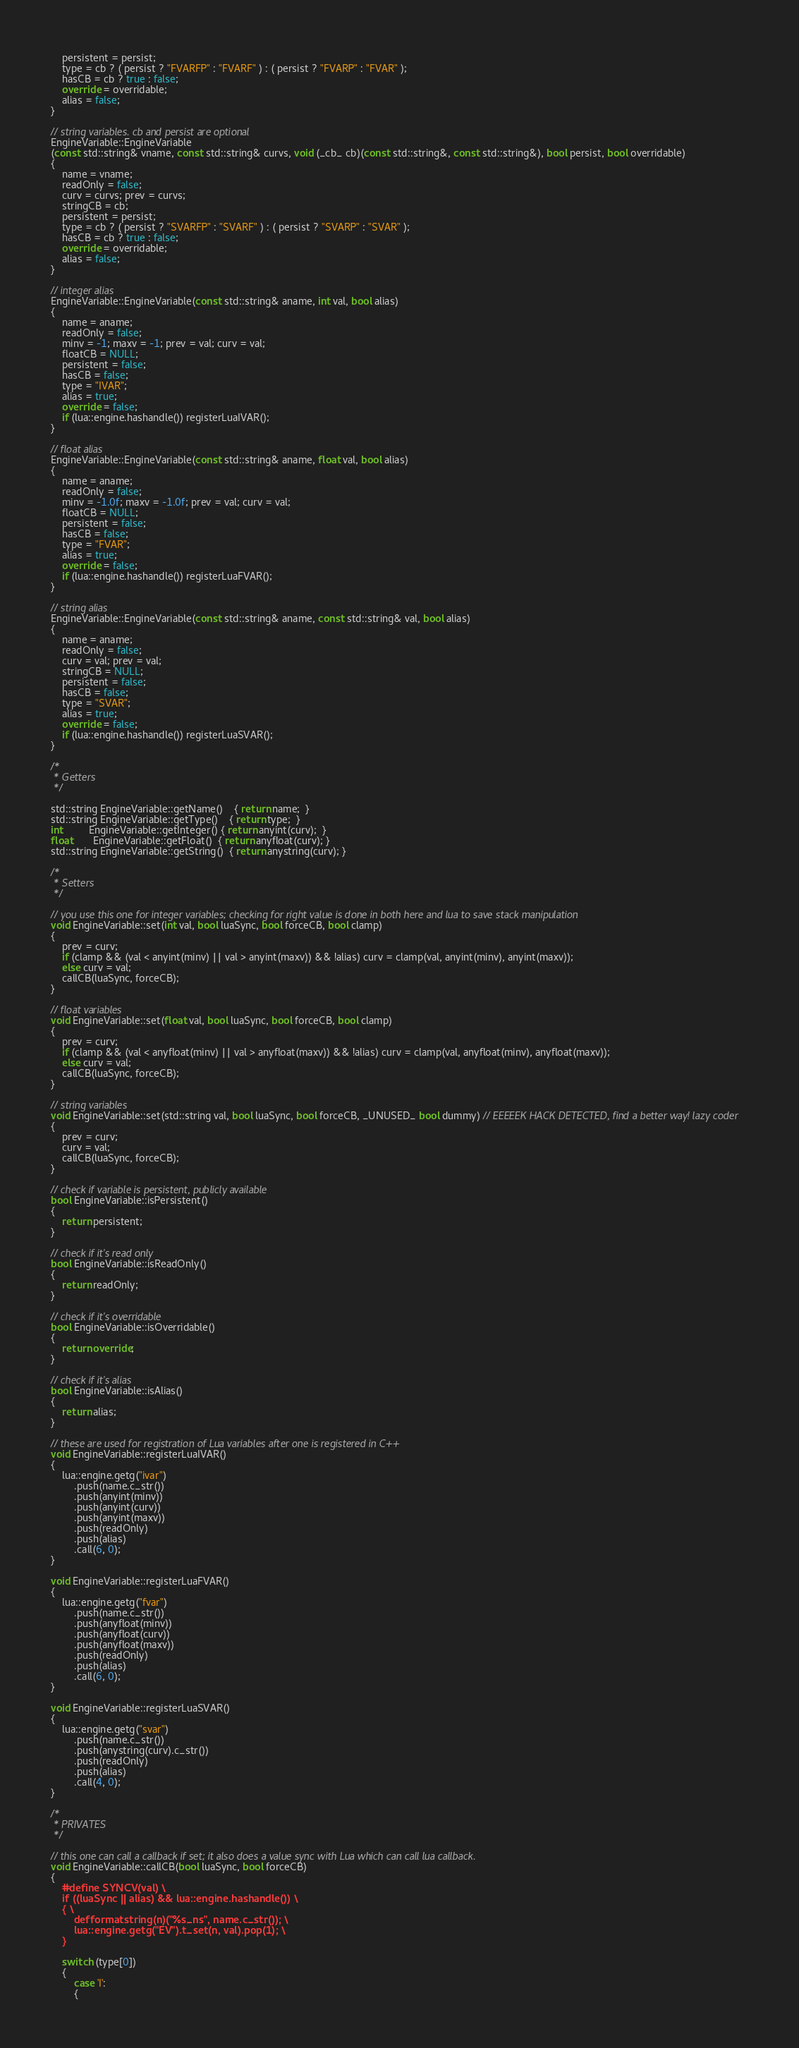Convert code to text. <code><loc_0><loc_0><loc_500><loc_500><_C++_>    persistent = persist;
    type = cb ? ( persist ? "FVARFP" : "FVARF" ) : ( persist ? "FVARP" : "FVAR" );
    hasCB = cb ? true : false;
    override = overridable;
    alias = false;
}

// string variables. cb and persist are optional
EngineVariable::EngineVariable
(const std::string& vname, const std::string& curvs, void (_cb_ cb)(const std::string&, const std::string&), bool persist, bool overridable)
{
    name = vname;
    readOnly = false;
    curv = curvs; prev = curvs;
    stringCB = cb;
    persistent = persist;
    type = cb ? ( persist ? "SVARFP" : "SVARF" ) : ( persist ? "SVARP" : "SVAR" );
    hasCB = cb ? true : false;
    override = overridable;
    alias = false;
}

// integer alias
EngineVariable::EngineVariable(const std::string& aname, int val, bool alias)
{
    name = aname;
    readOnly = false;
    minv = -1; maxv = -1; prev = val; curv = val;
    floatCB = NULL;
    persistent = false;
    hasCB = false;
    type = "IVAR";
    alias = true;
    override = false;
    if (lua::engine.hashandle()) registerLuaIVAR();
}

// float alias
EngineVariable::EngineVariable(const std::string& aname, float val, bool alias)
{
    name = aname;
    readOnly = false;
    minv = -1.0f; maxv = -1.0f; prev = val; curv = val;
    floatCB = NULL;
    persistent = false;
    hasCB = false;
    type = "FVAR";
    alias = true;
    override = false;
    if (lua::engine.hashandle()) registerLuaFVAR();
}

// string alias
EngineVariable::EngineVariable(const std::string& aname, const std::string& val, bool alias)
{
    name = aname;
    readOnly = false;
    curv = val; prev = val;
    stringCB = NULL;
    persistent = false;
    hasCB = false;
    type = "SVAR";
    alias = true;
    override = false;
    if (lua::engine.hashandle()) registerLuaSVAR();
}

/*
 * Getters
 */

std::string EngineVariable::getName()    { return name;  }
std::string EngineVariable::getType()    { return type;  }
int         EngineVariable::getInteger() { return anyint(curv);  }
float       EngineVariable::getFloat()  { return anyfloat(curv); }
std::string EngineVariable::getString()  { return anystring(curv); }

/*
 * Setters
 */

// you use this one for integer variables; checking for right value is done in both here and lua to save stack manipulation
void EngineVariable::set(int val, bool luaSync, bool forceCB, bool clamp)
{
    prev = curv;
    if (clamp && (val < anyint(minv) || val > anyint(maxv)) && !alias) curv = clamp(val, anyint(minv), anyint(maxv));
    else curv = val;
    callCB(luaSync, forceCB);
}

// float variables
void EngineVariable::set(float val, bool luaSync, bool forceCB, bool clamp)
{
    prev = curv;
    if (clamp && (val < anyfloat(minv) || val > anyfloat(maxv)) && !alias) curv = clamp(val, anyfloat(minv), anyfloat(maxv));
    else curv = val;
    callCB(luaSync, forceCB);
}

// string variables
void EngineVariable::set(std::string val, bool luaSync, bool forceCB, _UNUSED_ bool dummy) // EEEEEK HACK DETECTED, find a better way! lazy coder
{
    prev = curv;
    curv = val;
    callCB(luaSync, forceCB);
}

// check if variable is persistent, publicly available
bool EngineVariable::isPersistent()
{
    return persistent;
}

// check if it's read only
bool EngineVariable::isReadOnly()
{
    return readOnly;
}

// check if it's overridable
bool EngineVariable::isOverridable()
{
    return override;
}

// check if it's alias
bool EngineVariable::isAlias()
{
    return alias;
}

// these are used for registration of Lua variables after one is registered in C++
void EngineVariable::registerLuaIVAR()
{
    lua::engine.getg("ivar")
        .push(name.c_str())
        .push(anyint(minv))
        .push(anyint(curv))
        .push(anyint(maxv))
        .push(readOnly)
        .push(alias)
        .call(6, 0);
}

void EngineVariable::registerLuaFVAR()
{
    lua::engine.getg("fvar")
        .push(name.c_str())
        .push(anyfloat(minv))
        .push(anyfloat(curv))
        .push(anyfloat(maxv))
        .push(readOnly)
        .push(alias)
        .call(6, 0);
}

void EngineVariable::registerLuaSVAR()
{
    lua::engine.getg("svar")
        .push(name.c_str())
        .push(anystring(curv).c_str())
        .push(readOnly)
        .push(alias)
        .call(4, 0);
}

/*
 * PRIVATES
 */

// this one can call a callback if set; it also does a value sync with Lua which can call lua callback.
void EngineVariable::callCB(bool luaSync, bool forceCB)
{
    #define SYNCV(val) \
    if ((luaSync || alias) && lua::engine.hashandle()) \
    { \
        defformatstring(n)("%s_ns", name.c_str()); \
        lua::engine.getg("EV").t_set(n, val).pop(1); \
    }

    switch (type[0])
    {
        case 'I':
        {</code> 